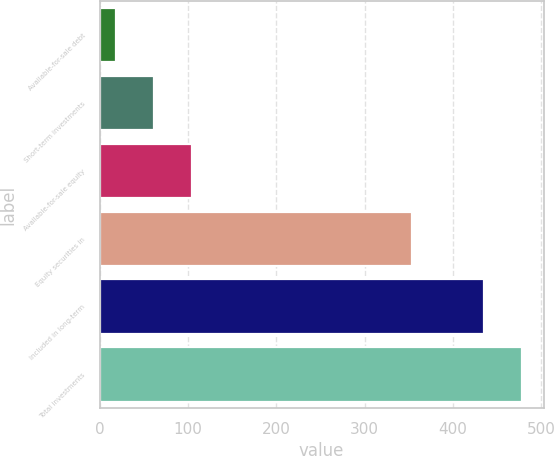<chart> <loc_0><loc_0><loc_500><loc_500><bar_chart><fcel>Available-for-sale debt<fcel>Short-term investments<fcel>Available-for-sale equity<fcel>Equity securities in<fcel>Included in long-term<fcel>Total investments<nl><fcel>18<fcel>61.5<fcel>105<fcel>353<fcel>435<fcel>478.5<nl></chart> 